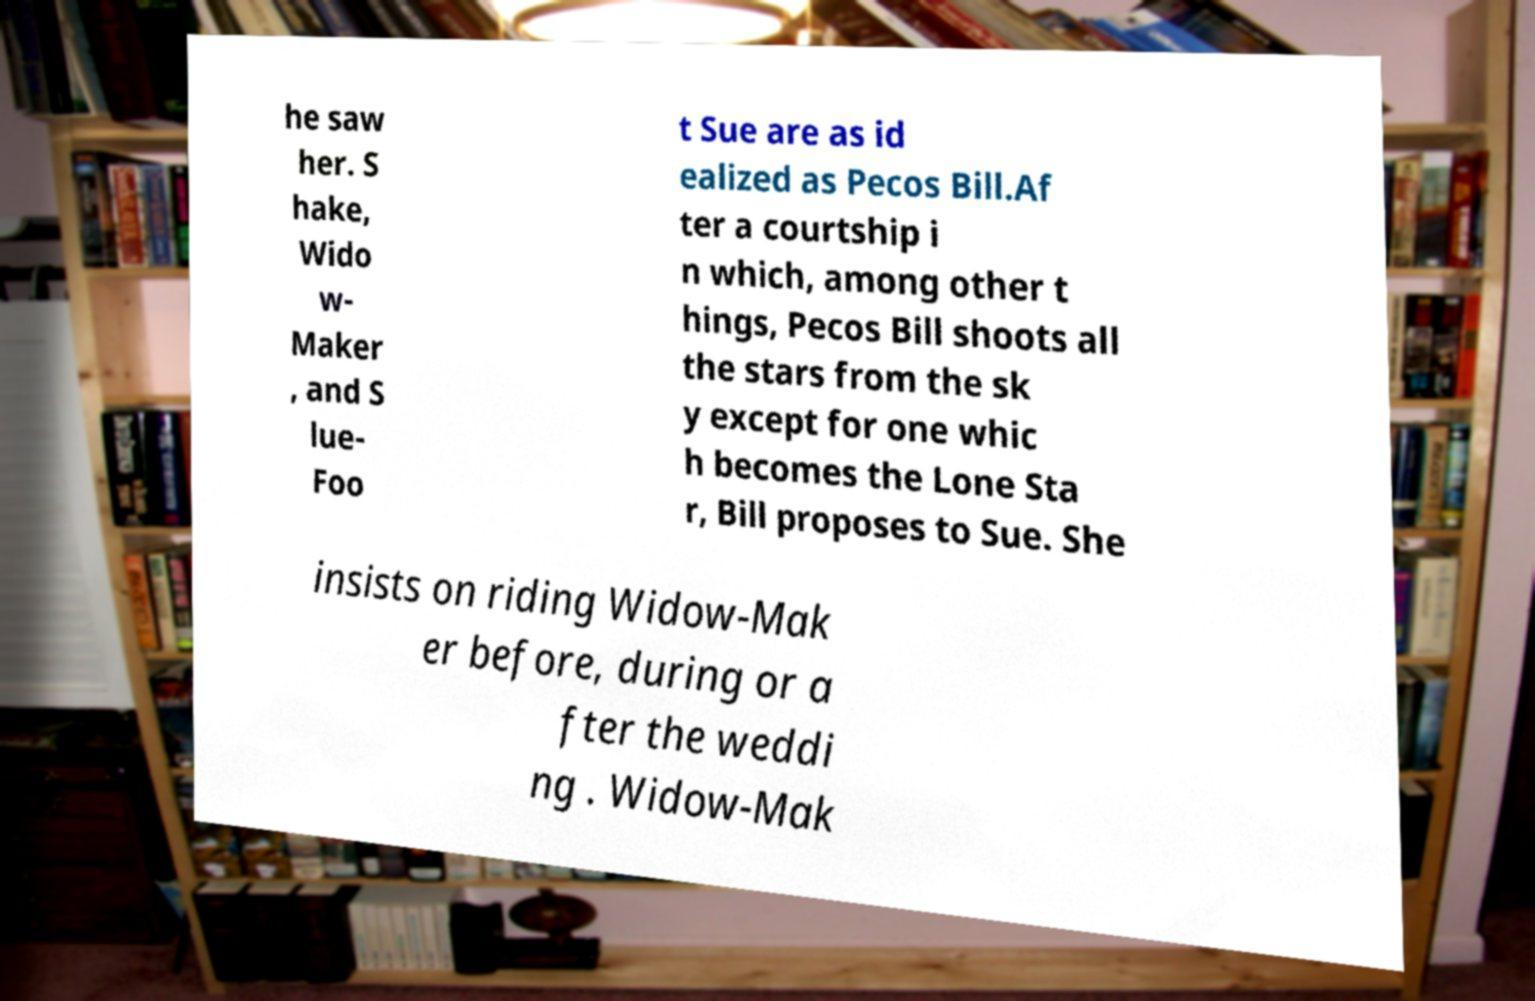There's text embedded in this image that I need extracted. Can you transcribe it verbatim? he saw her. S hake, Wido w- Maker , and S lue- Foo t Sue are as id ealized as Pecos Bill.Af ter a courtship i n which, among other t hings, Pecos Bill shoots all the stars from the sk y except for one whic h becomes the Lone Sta r, Bill proposes to Sue. She insists on riding Widow-Mak er before, during or a fter the weddi ng . Widow-Mak 